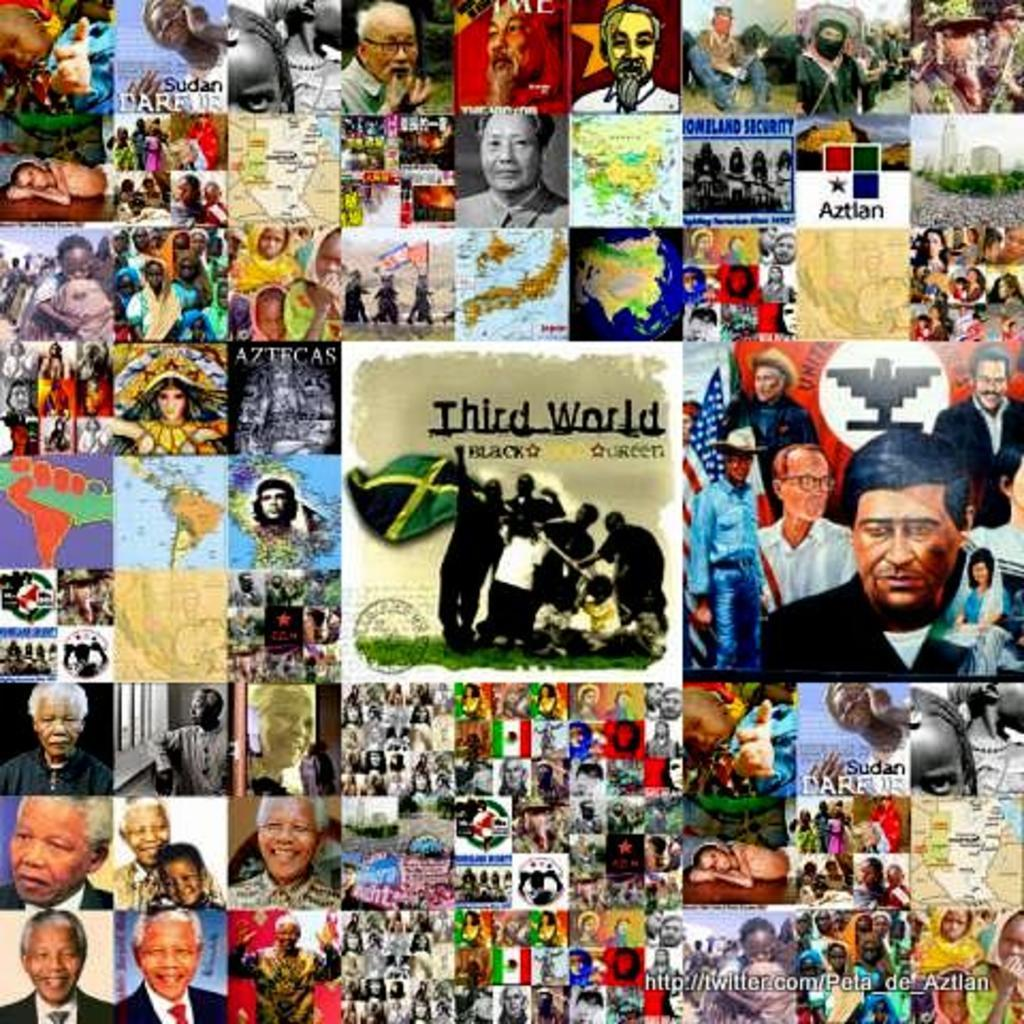What type of image is being described? The image is a collage. What elements can be found in the collage? There are people, flags, maps, and text in the image. Where is the watermark located in the image? The watermark is in the bottom right corner of the image. Can you tell me how many rabbits are hopping around in the image? There are no rabbits present in the image; it contains people, flags, maps, and text. What type of calculator is being used by the people in the image? There is no calculator visible in the image; it only features people, flags, maps, and text. 